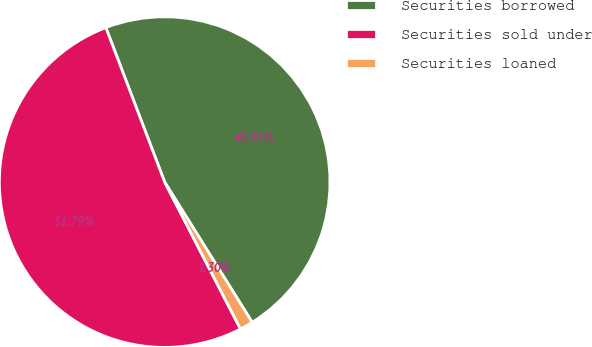<chart> <loc_0><loc_0><loc_500><loc_500><pie_chart><fcel>Securities borrowed<fcel>Securities sold under<fcel>Securities loaned<nl><fcel>46.91%<fcel>51.79%<fcel>1.3%<nl></chart> 